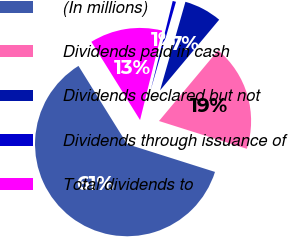Convert chart to OTSL. <chart><loc_0><loc_0><loc_500><loc_500><pie_chart><fcel>(In millions)<fcel>Dividends paid in cash<fcel>Dividends declared but not<fcel>Dividends through issuance of<fcel>Total dividends to<nl><fcel>61.27%<fcel>18.79%<fcel>6.65%<fcel>0.58%<fcel>12.72%<nl></chart> 